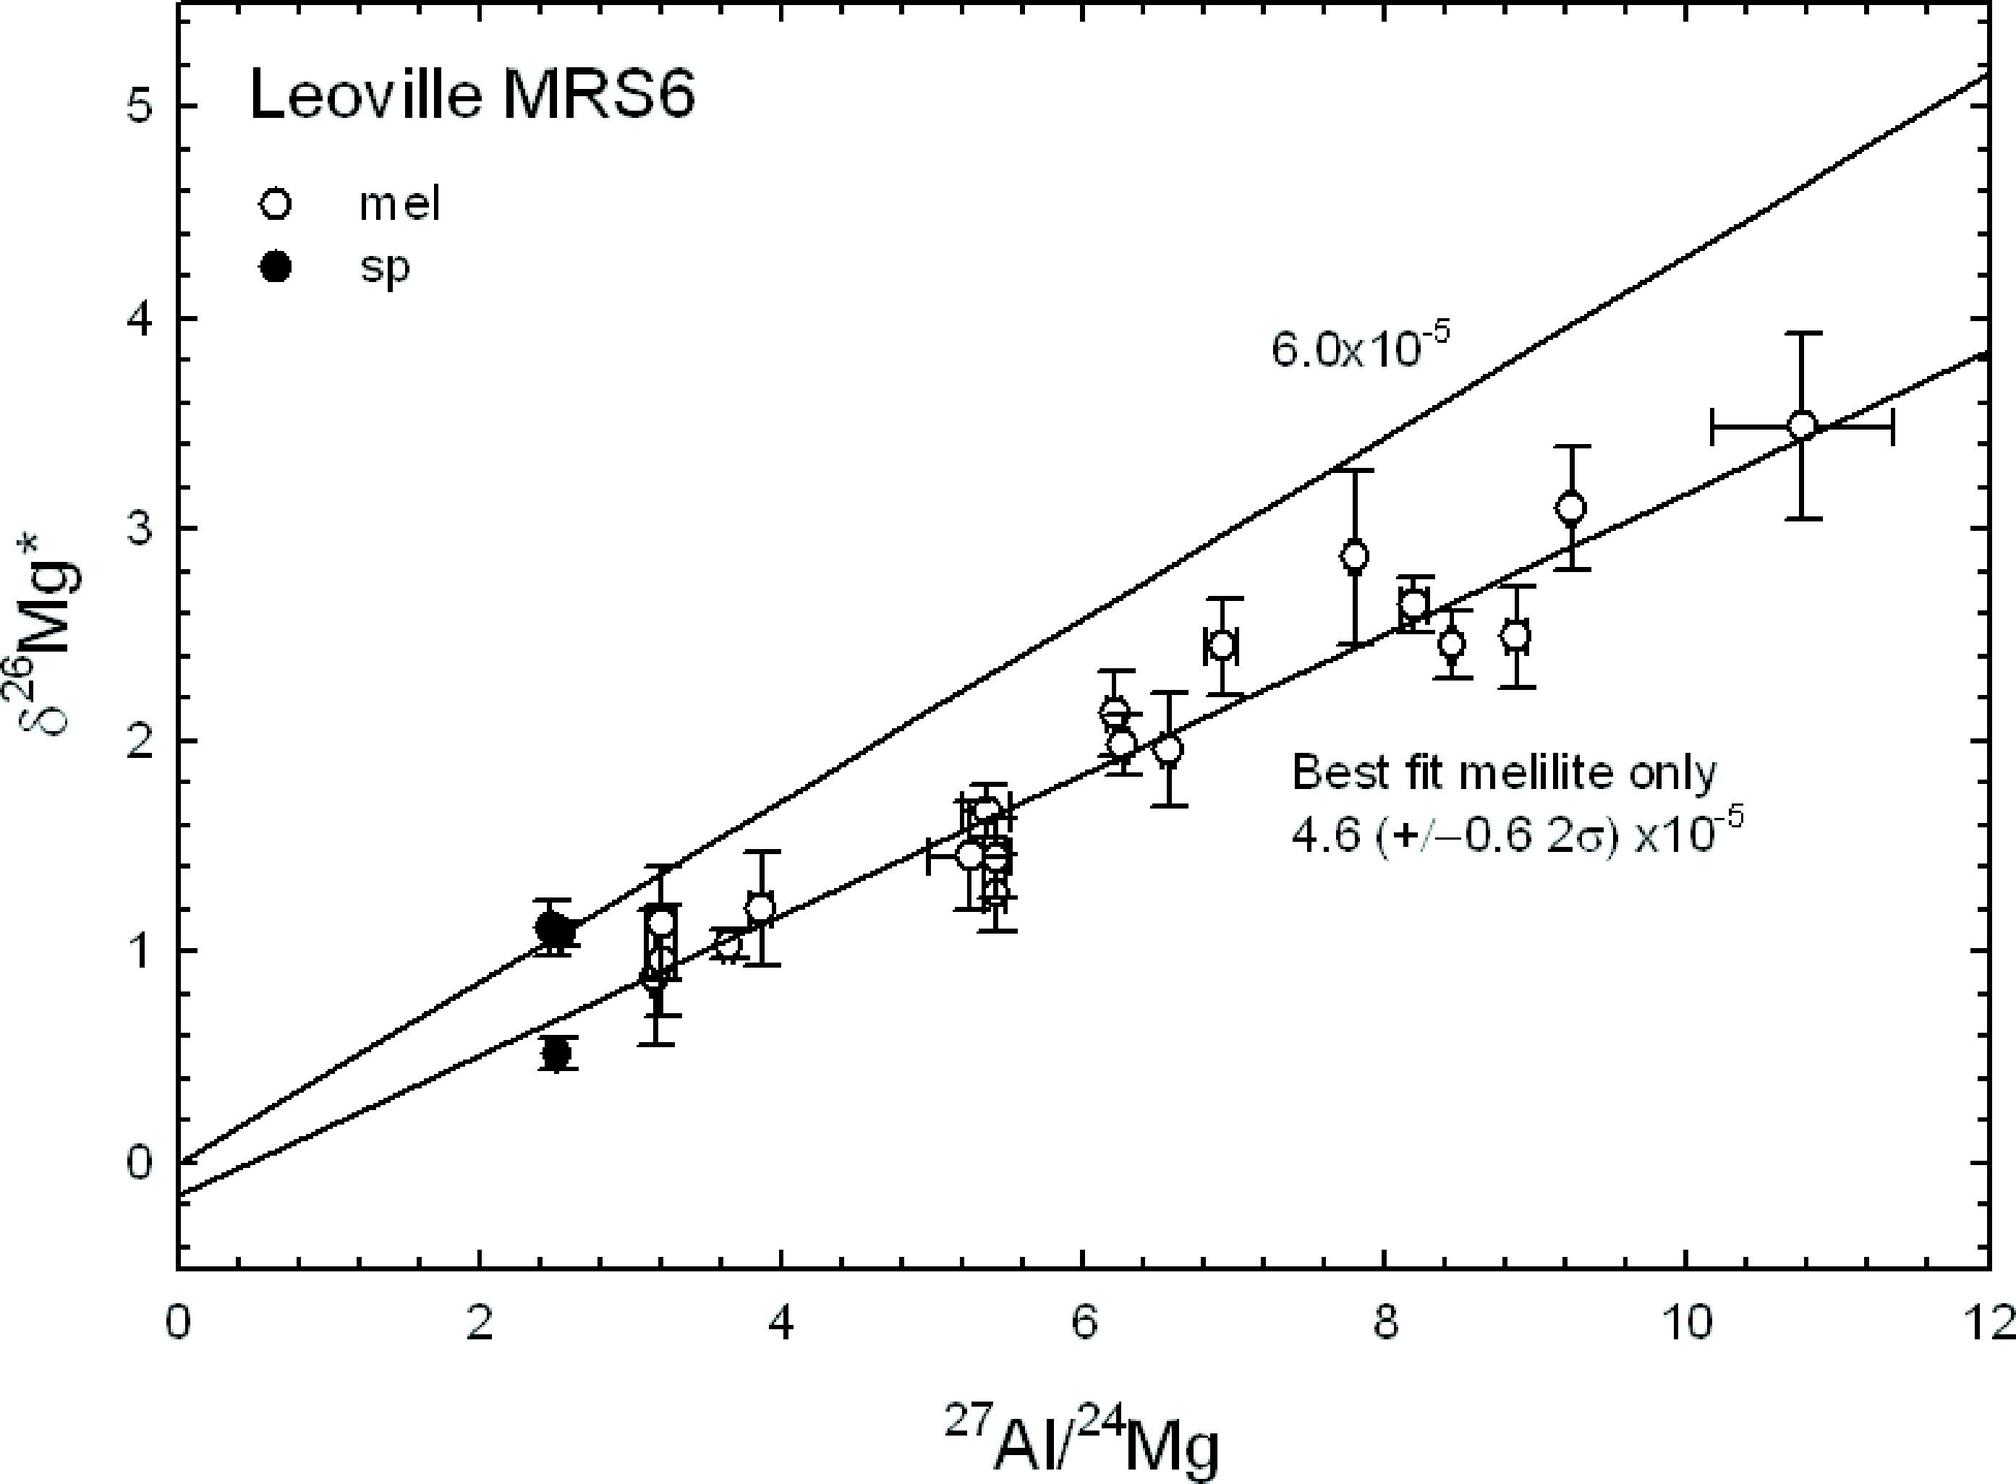What does the intersection of the two trend lines on the graph indicate? The error margin of the data The point where both sets of data are equal The starting point of measurements The maximum value of δ26Mg* recorded - The intersection of the trend lines indicates the point where the two sets of data, melilite and spinel (sp), have the same δ26Mg* value, which means the isotopic ratio of Aluminum to Magnesium is the same for both. Therefore, the correct answer is B. 